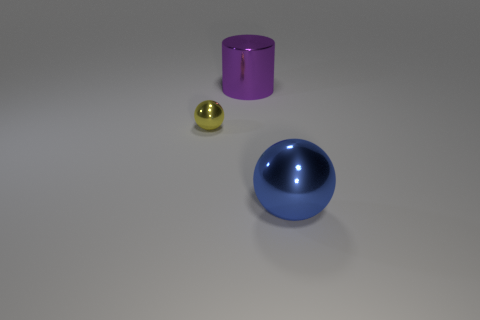What number of other things are there of the same size as the cylinder?
Offer a terse response. 1. What size is the blue metal sphere?
Offer a very short reply. Large. Are there any purple metallic things that have the same shape as the tiny yellow thing?
Your answer should be compact. No. What is the material of the ball that is the same size as the purple object?
Provide a succinct answer. Metal. There is a sphere right of the large cylinder; what size is it?
Your answer should be compact. Large. There is a sphere that is in front of the small yellow ball; does it have the same size as the thing behind the tiny yellow thing?
Provide a succinct answer. Yes. What number of small gray blocks are the same material as the big blue thing?
Ensure brevity in your answer.  0. What is the color of the tiny metal thing?
Your answer should be very brief. Yellow. There is a big blue sphere; are there any shiny things to the left of it?
Keep it short and to the point. Yes. What number of small metal objects have the same color as the large cylinder?
Give a very brief answer. 0. 